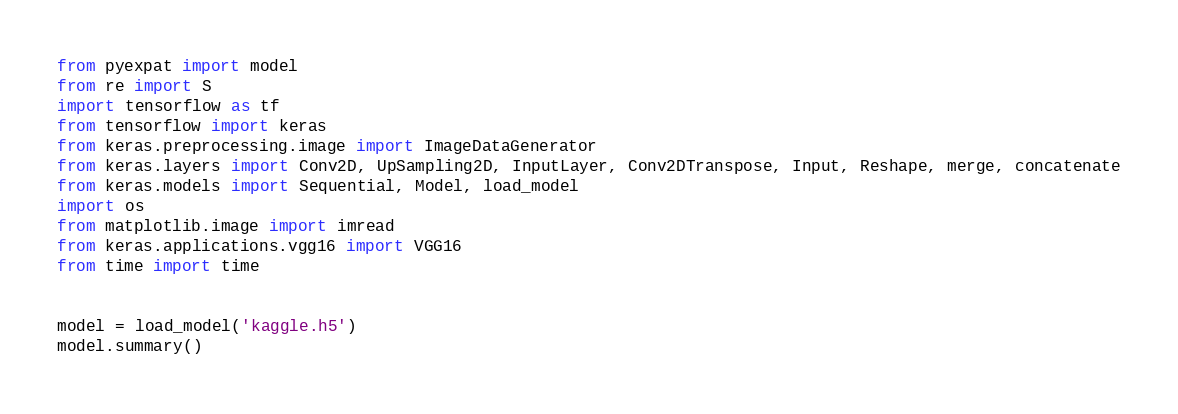<code> <loc_0><loc_0><loc_500><loc_500><_Python_>from pyexpat import model
from re import S
import tensorflow as tf
from tensorflow import keras
from keras.preprocessing.image import ImageDataGenerator
from keras.layers import Conv2D, UpSampling2D, InputLayer, Conv2DTranspose, Input, Reshape, merge, concatenate
from keras.models import Sequential, Model, load_model
import os
from matplotlib.image import imread
from keras.applications.vgg16 import VGG16
from time import time


model = load_model('kaggle.h5')
model.summary()</code> 